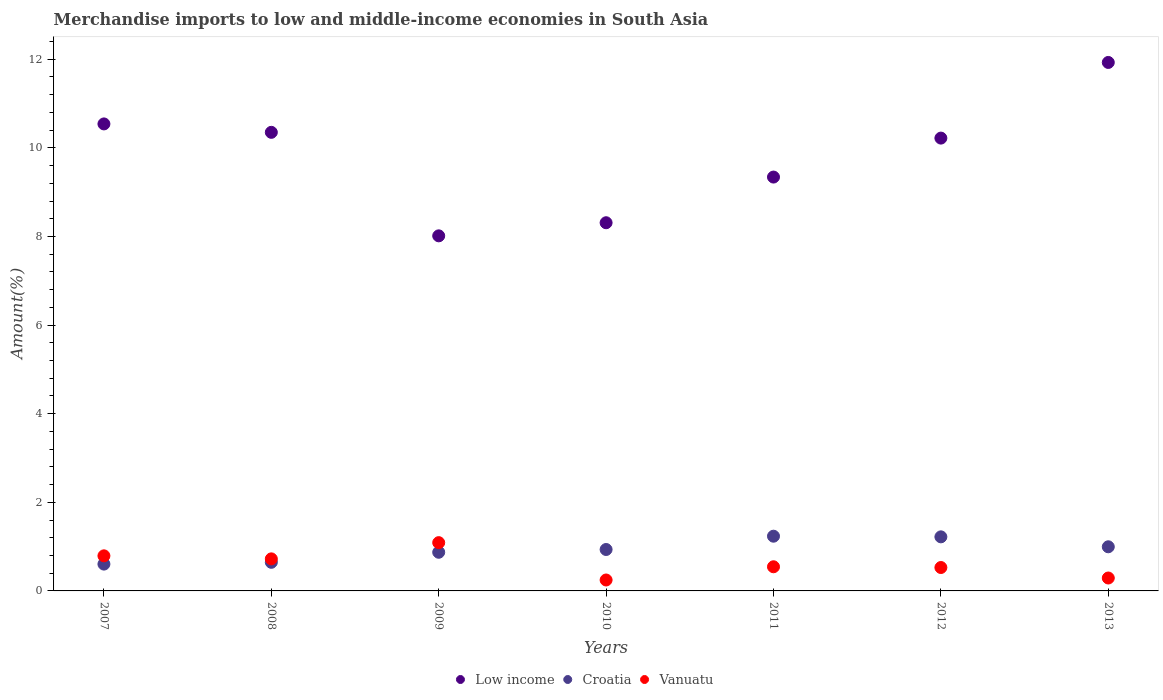What is the percentage of amount earned from merchandise imports in Croatia in 2011?
Make the answer very short. 1.24. Across all years, what is the maximum percentage of amount earned from merchandise imports in Croatia?
Your response must be concise. 1.24. Across all years, what is the minimum percentage of amount earned from merchandise imports in Vanuatu?
Your answer should be compact. 0.25. In which year was the percentage of amount earned from merchandise imports in Vanuatu maximum?
Offer a very short reply. 2009. What is the total percentage of amount earned from merchandise imports in Vanuatu in the graph?
Your answer should be compact. 4.22. What is the difference between the percentage of amount earned from merchandise imports in Low income in 2007 and that in 2011?
Your answer should be compact. 1.2. What is the difference between the percentage of amount earned from merchandise imports in Low income in 2010 and the percentage of amount earned from merchandise imports in Croatia in 2007?
Offer a very short reply. 7.7. What is the average percentage of amount earned from merchandise imports in Croatia per year?
Offer a terse response. 0.93. In the year 2010, what is the difference between the percentage of amount earned from merchandise imports in Low income and percentage of amount earned from merchandise imports in Croatia?
Provide a succinct answer. 7.38. What is the ratio of the percentage of amount earned from merchandise imports in Croatia in 2008 to that in 2013?
Give a very brief answer. 0.65. What is the difference between the highest and the second highest percentage of amount earned from merchandise imports in Vanuatu?
Your answer should be compact. 0.3. What is the difference between the highest and the lowest percentage of amount earned from merchandise imports in Low income?
Provide a succinct answer. 3.91. In how many years, is the percentage of amount earned from merchandise imports in Low income greater than the average percentage of amount earned from merchandise imports in Low income taken over all years?
Give a very brief answer. 4. Is the sum of the percentage of amount earned from merchandise imports in Croatia in 2010 and 2013 greater than the maximum percentage of amount earned from merchandise imports in Low income across all years?
Offer a very short reply. No. Does the percentage of amount earned from merchandise imports in Croatia monotonically increase over the years?
Ensure brevity in your answer.  No. Is the percentage of amount earned from merchandise imports in Croatia strictly greater than the percentage of amount earned from merchandise imports in Vanuatu over the years?
Provide a short and direct response. No. What is the difference between two consecutive major ticks on the Y-axis?
Your response must be concise. 2. Are the values on the major ticks of Y-axis written in scientific E-notation?
Offer a terse response. No. Does the graph contain any zero values?
Keep it short and to the point. No. How are the legend labels stacked?
Offer a very short reply. Horizontal. What is the title of the graph?
Offer a very short reply. Merchandise imports to low and middle-income economies in South Asia. Does "Syrian Arab Republic" appear as one of the legend labels in the graph?
Give a very brief answer. No. What is the label or title of the Y-axis?
Provide a succinct answer. Amount(%). What is the Amount(%) of Low income in 2007?
Give a very brief answer. 10.54. What is the Amount(%) in Croatia in 2007?
Provide a succinct answer. 0.61. What is the Amount(%) of Vanuatu in 2007?
Ensure brevity in your answer.  0.79. What is the Amount(%) in Low income in 2008?
Your answer should be very brief. 10.35. What is the Amount(%) in Croatia in 2008?
Make the answer very short. 0.65. What is the Amount(%) of Vanuatu in 2008?
Your answer should be compact. 0.72. What is the Amount(%) in Low income in 2009?
Make the answer very short. 8.01. What is the Amount(%) in Croatia in 2009?
Offer a very short reply. 0.87. What is the Amount(%) of Vanuatu in 2009?
Give a very brief answer. 1.09. What is the Amount(%) of Low income in 2010?
Ensure brevity in your answer.  8.31. What is the Amount(%) of Croatia in 2010?
Make the answer very short. 0.93. What is the Amount(%) of Vanuatu in 2010?
Give a very brief answer. 0.25. What is the Amount(%) of Low income in 2011?
Ensure brevity in your answer.  9.34. What is the Amount(%) of Croatia in 2011?
Keep it short and to the point. 1.24. What is the Amount(%) of Vanuatu in 2011?
Your answer should be compact. 0.54. What is the Amount(%) in Low income in 2012?
Keep it short and to the point. 10.22. What is the Amount(%) in Croatia in 2012?
Make the answer very short. 1.22. What is the Amount(%) of Vanuatu in 2012?
Your answer should be compact. 0.53. What is the Amount(%) of Low income in 2013?
Your answer should be very brief. 11.93. What is the Amount(%) in Croatia in 2013?
Give a very brief answer. 1. What is the Amount(%) in Vanuatu in 2013?
Offer a terse response. 0.29. Across all years, what is the maximum Amount(%) of Low income?
Ensure brevity in your answer.  11.93. Across all years, what is the maximum Amount(%) of Croatia?
Provide a succinct answer. 1.24. Across all years, what is the maximum Amount(%) in Vanuatu?
Provide a short and direct response. 1.09. Across all years, what is the minimum Amount(%) of Low income?
Offer a terse response. 8.01. Across all years, what is the minimum Amount(%) of Croatia?
Give a very brief answer. 0.61. Across all years, what is the minimum Amount(%) in Vanuatu?
Your answer should be compact. 0.25. What is the total Amount(%) in Low income in the graph?
Provide a short and direct response. 68.71. What is the total Amount(%) in Croatia in the graph?
Keep it short and to the point. 6.51. What is the total Amount(%) of Vanuatu in the graph?
Provide a short and direct response. 4.22. What is the difference between the Amount(%) in Low income in 2007 and that in 2008?
Offer a very short reply. 0.19. What is the difference between the Amount(%) in Croatia in 2007 and that in 2008?
Give a very brief answer. -0.04. What is the difference between the Amount(%) of Vanuatu in 2007 and that in 2008?
Ensure brevity in your answer.  0.07. What is the difference between the Amount(%) in Low income in 2007 and that in 2009?
Ensure brevity in your answer.  2.53. What is the difference between the Amount(%) of Croatia in 2007 and that in 2009?
Your response must be concise. -0.27. What is the difference between the Amount(%) in Vanuatu in 2007 and that in 2009?
Provide a succinct answer. -0.3. What is the difference between the Amount(%) of Low income in 2007 and that in 2010?
Keep it short and to the point. 2.23. What is the difference between the Amount(%) of Croatia in 2007 and that in 2010?
Provide a succinct answer. -0.33. What is the difference between the Amount(%) in Vanuatu in 2007 and that in 2010?
Make the answer very short. 0.55. What is the difference between the Amount(%) of Low income in 2007 and that in 2011?
Provide a succinct answer. 1.2. What is the difference between the Amount(%) in Croatia in 2007 and that in 2011?
Offer a very short reply. -0.63. What is the difference between the Amount(%) in Vanuatu in 2007 and that in 2011?
Offer a terse response. 0.25. What is the difference between the Amount(%) of Low income in 2007 and that in 2012?
Your response must be concise. 0.32. What is the difference between the Amount(%) in Croatia in 2007 and that in 2012?
Keep it short and to the point. -0.62. What is the difference between the Amount(%) in Vanuatu in 2007 and that in 2012?
Your answer should be compact. 0.26. What is the difference between the Amount(%) of Low income in 2007 and that in 2013?
Make the answer very short. -1.39. What is the difference between the Amount(%) in Croatia in 2007 and that in 2013?
Give a very brief answer. -0.39. What is the difference between the Amount(%) of Vanuatu in 2007 and that in 2013?
Provide a short and direct response. 0.5. What is the difference between the Amount(%) of Low income in 2008 and that in 2009?
Keep it short and to the point. 2.34. What is the difference between the Amount(%) of Croatia in 2008 and that in 2009?
Give a very brief answer. -0.23. What is the difference between the Amount(%) in Vanuatu in 2008 and that in 2009?
Offer a terse response. -0.37. What is the difference between the Amount(%) in Low income in 2008 and that in 2010?
Provide a succinct answer. 2.04. What is the difference between the Amount(%) of Croatia in 2008 and that in 2010?
Your answer should be compact. -0.29. What is the difference between the Amount(%) in Vanuatu in 2008 and that in 2010?
Offer a very short reply. 0.48. What is the difference between the Amount(%) in Low income in 2008 and that in 2011?
Your response must be concise. 1.01. What is the difference between the Amount(%) in Croatia in 2008 and that in 2011?
Provide a succinct answer. -0.59. What is the difference between the Amount(%) in Vanuatu in 2008 and that in 2011?
Make the answer very short. 0.18. What is the difference between the Amount(%) of Low income in 2008 and that in 2012?
Keep it short and to the point. 0.13. What is the difference between the Amount(%) of Croatia in 2008 and that in 2012?
Keep it short and to the point. -0.57. What is the difference between the Amount(%) of Vanuatu in 2008 and that in 2012?
Make the answer very short. 0.2. What is the difference between the Amount(%) of Low income in 2008 and that in 2013?
Give a very brief answer. -1.58. What is the difference between the Amount(%) of Croatia in 2008 and that in 2013?
Keep it short and to the point. -0.35. What is the difference between the Amount(%) in Vanuatu in 2008 and that in 2013?
Provide a succinct answer. 0.43. What is the difference between the Amount(%) in Low income in 2009 and that in 2010?
Provide a short and direct response. -0.3. What is the difference between the Amount(%) of Croatia in 2009 and that in 2010?
Give a very brief answer. -0.06. What is the difference between the Amount(%) in Vanuatu in 2009 and that in 2010?
Offer a very short reply. 0.84. What is the difference between the Amount(%) of Low income in 2009 and that in 2011?
Provide a succinct answer. -1.33. What is the difference between the Amount(%) in Croatia in 2009 and that in 2011?
Give a very brief answer. -0.36. What is the difference between the Amount(%) of Vanuatu in 2009 and that in 2011?
Your answer should be compact. 0.54. What is the difference between the Amount(%) of Low income in 2009 and that in 2012?
Ensure brevity in your answer.  -2.21. What is the difference between the Amount(%) of Croatia in 2009 and that in 2012?
Give a very brief answer. -0.35. What is the difference between the Amount(%) of Vanuatu in 2009 and that in 2012?
Offer a terse response. 0.56. What is the difference between the Amount(%) in Low income in 2009 and that in 2013?
Your answer should be very brief. -3.91. What is the difference between the Amount(%) in Croatia in 2009 and that in 2013?
Provide a succinct answer. -0.12. What is the difference between the Amount(%) of Vanuatu in 2009 and that in 2013?
Keep it short and to the point. 0.8. What is the difference between the Amount(%) of Low income in 2010 and that in 2011?
Your answer should be very brief. -1.03. What is the difference between the Amount(%) of Croatia in 2010 and that in 2011?
Your answer should be very brief. -0.3. What is the difference between the Amount(%) of Vanuatu in 2010 and that in 2011?
Ensure brevity in your answer.  -0.3. What is the difference between the Amount(%) in Low income in 2010 and that in 2012?
Keep it short and to the point. -1.91. What is the difference between the Amount(%) of Croatia in 2010 and that in 2012?
Your answer should be very brief. -0.29. What is the difference between the Amount(%) in Vanuatu in 2010 and that in 2012?
Provide a succinct answer. -0.28. What is the difference between the Amount(%) in Low income in 2010 and that in 2013?
Keep it short and to the point. -3.62. What is the difference between the Amount(%) of Croatia in 2010 and that in 2013?
Keep it short and to the point. -0.06. What is the difference between the Amount(%) in Vanuatu in 2010 and that in 2013?
Make the answer very short. -0.04. What is the difference between the Amount(%) of Low income in 2011 and that in 2012?
Your answer should be compact. -0.88. What is the difference between the Amount(%) in Croatia in 2011 and that in 2012?
Keep it short and to the point. 0.01. What is the difference between the Amount(%) in Vanuatu in 2011 and that in 2012?
Offer a very short reply. 0.02. What is the difference between the Amount(%) in Low income in 2011 and that in 2013?
Offer a very short reply. -2.59. What is the difference between the Amount(%) in Croatia in 2011 and that in 2013?
Offer a very short reply. 0.24. What is the difference between the Amount(%) in Vanuatu in 2011 and that in 2013?
Provide a short and direct response. 0.25. What is the difference between the Amount(%) in Low income in 2012 and that in 2013?
Keep it short and to the point. -1.71. What is the difference between the Amount(%) in Croatia in 2012 and that in 2013?
Your answer should be very brief. 0.22. What is the difference between the Amount(%) of Vanuatu in 2012 and that in 2013?
Offer a very short reply. 0.24. What is the difference between the Amount(%) of Low income in 2007 and the Amount(%) of Croatia in 2008?
Keep it short and to the point. 9.89. What is the difference between the Amount(%) in Low income in 2007 and the Amount(%) in Vanuatu in 2008?
Your answer should be compact. 9.82. What is the difference between the Amount(%) in Croatia in 2007 and the Amount(%) in Vanuatu in 2008?
Your response must be concise. -0.12. What is the difference between the Amount(%) of Low income in 2007 and the Amount(%) of Croatia in 2009?
Offer a terse response. 9.67. What is the difference between the Amount(%) of Low income in 2007 and the Amount(%) of Vanuatu in 2009?
Your answer should be compact. 9.45. What is the difference between the Amount(%) in Croatia in 2007 and the Amount(%) in Vanuatu in 2009?
Keep it short and to the point. -0.48. What is the difference between the Amount(%) of Low income in 2007 and the Amount(%) of Croatia in 2010?
Make the answer very short. 9.61. What is the difference between the Amount(%) in Low income in 2007 and the Amount(%) in Vanuatu in 2010?
Your response must be concise. 10.29. What is the difference between the Amount(%) of Croatia in 2007 and the Amount(%) of Vanuatu in 2010?
Your answer should be very brief. 0.36. What is the difference between the Amount(%) of Low income in 2007 and the Amount(%) of Croatia in 2011?
Provide a short and direct response. 9.31. What is the difference between the Amount(%) in Low income in 2007 and the Amount(%) in Vanuatu in 2011?
Offer a terse response. 10. What is the difference between the Amount(%) in Croatia in 2007 and the Amount(%) in Vanuatu in 2011?
Offer a terse response. 0.06. What is the difference between the Amount(%) of Low income in 2007 and the Amount(%) of Croatia in 2012?
Your answer should be compact. 9.32. What is the difference between the Amount(%) in Low income in 2007 and the Amount(%) in Vanuatu in 2012?
Your answer should be compact. 10.01. What is the difference between the Amount(%) of Croatia in 2007 and the Amount(%) of Vanuatu in 2012?
Your response must be concise. 0.08. What is the difference between the Amount(%) of Low income in 2007 and the Amount(%) of Croatia in 2013?
Make the answer very short. 9.54. What is the difference between the Amount(%) of Low income in 2007 and the Amount(%) of Vanuatu in 2013?
Offer a very short reply. 10.25. What is the difference between the Amount(%) in Croatia in 2007 and the Amount(%) in Vanuatu in 2013?
Provide a short and direct response. 0.31. What is the difference between the Amount(%) in Low income in 2008 and the Amount(%) in Croatia in 2009?
Make the answer very short. 9.48. What is the difference between the Amount(%) in Low income in 2008 and the Amount(%) in Vanuatu in 2009?
Your answer should be very brief. 9.26. What is the difference between the Amount(%) of Croatia in 2008 and the Amount(%) of Vanuatu in 2009?
Offer a very short reply. -0.44. What is the difference between the Amount(%) in Low income in 2008 and the Amount(%) in Croatia in 2010?
Provide a short and direct response. 9.42. What is the difference between the Amount(%) in Low income in 2008 and the Amount(%) in Vanuatu in 2010?
Your answer should be compact. 10.1. What is the difference between the Amount(%) in Croatia in 2008 and the Amount(%) in Vanuatu in 2010?
Keep it short and to the point. 0.4. What is the difference between the Amount(%) of Low income in 2008 and the Amount(%) of Croatia in 2011?
Provide a short and direct response. 9.12. What is the difference between the Amount(%) in Low income in 2008 and the Amount(%) in Vanuatu in 2011?
Make the answer very short. 9.81. What is the difference between the Amount(%) in Croatia in 2008 and the Amount(%) in Vanuatu in 2011?
Provide a short and direct response. 0.1. What is the difference between the Amount(%) of Low income in 2008 and the Amount(%) of Croatia in 2012?
Give a very brief answer. 9.13. What is the difference between the Amount(%) in Low income in 2008 and the Amount(%) in Vanuatu in 2012?
Ensure brevity in your answer.  9.82. What is the difference between the Amount(%) in Croatia in 2008 and the Amount(%) in Vanuatu in 2012?
Ensure brevity in your answer.  0.12. What is the difference between the Amount(%) of Low income in 2008 and the Amount(%) of Croatia in 2013?
Your answer should be compact. 9.35. What is the difference between the Amount(%) in Low income in 2008 and the Amount(%) in Vanuatu in 2013?
Offer a very short reply. 10.06. What is the difference between the Amount(%) of Croatia in 2008 and the Amount(%) of Vanuatu in 2013?
Give a very brief answer. 0.35. What is the difference between the Amount(%) in Low income in 2009 and the Amount(%) in Croatia in 2010?
Provide a succinct answer. 7.08. What is the difference between the Amount(%) of Low income in 2009 and the Amount(%) of Vanuatu in 2010?
Provide a short and direct response. 7.77. What is the difference between the Amount(%) in Croatia in 2009 and the Amount(%) in Vanuatu in 2010?
Your response must be concise. 0.63. What is the difference between the Amount(%) of Low income in 2009 and the Amount(%) of Croatia in 2011?
Your answer should be compact. 6.78. What is the difference between the Amount(%) in Low income in 2009 and the Amount(%) in Vanuatu in 2011?
Give a very brief answer. 7.47. What is the difference between the Amount(%) of Croatia in 2009 and the Amount(%) of Vanuatu in 2011?
Offer a terse response. 0.33. What is the difference between the Amount(%) of Low income in 2009 and the Amount(%) of Croatia in 2012?
Your response must be concise. 6.79. What is the difference between the Amount(%) in Low income in 2009 and the Amount(%) in Vanuatu in 2012?
Make the answer very short. 7.49. What is the difference between the Amount(%) of Croatia in 2009 and the Amount(%) of Vanuatu in 2012?
Keep it short and to the point. 0.34. What is the difference between the Amount(%) in Low income in 2009 and the Amount(%) in Croatia in 2013?
Your response must be concise. 7.02. What is the difference between the Amount(%) of Low income in 2009 and the Amount(%) of Vanuatu in 2013?
Offer a very short reply. 7.72. What is the difference between the Amount(%) in Croatia in 2009 and the Amount(%) in Vanuatu in 2013?
Give a very brief answer. 0.58. What is the difference between the Amount(%) of Low income in 2010 and the Amount(%) of Croatia in 2011?
Provide a succinct answer. 7.08. What is the difference between the Amount(%) of Low income in 2010 and the Amount(%) of Vanuatu in 2011?
Your answer should be compact. 7.77. What is the difference between the Amount(%) in Croatia in 2010 and the Amount(%) in Vanuatu in 2011?
Make the answer very short. 0.39. What is the difference between the Amount(%) of Low income in 2010 and the Amount(%) of Croatia in 2012?
Your response must be concise. 7.09. What is the difference between the Amount(%) in Low income in 2010 and the Amount(%) in Vanuatu in 2012?
Keep it short and to the point. 7.78. What is the difference between the Amount(%) of Croatia in 2010 and the Amount(%) of Vanuatu in 2012?
Your answer should be compact. 0.41. What is the difference between the Amount(%) of Low income in 2010 and the Amount(%) of Croatia in 2013?
Give a very brief answer. 7.31. What is the difference between the Amount(%) of Low income in 2010 and the Amount(%) of Vanuatu in 2013?
Your answer should be very brief. 8.02. What is the difference between the Amount(%) in Croatia in 2010 and the Amount(%) in Vanuatu in 2013?
Your answer should be compact. 0.64. What is the difference between the Amount(%) of Low income in 2011 and the Amount(%) of Croatia in 2012?
Your answer should be very brief. 8.12. What is the difference between the Amount(%) of Low income in 2011 and the Amount(%) of Vanuatu in 2012?
Offer a very short reply. 8.81. What is the difference between the Amount(%) in Croatia in 2011 and the Amount(%) in Vanuatu in 2012?
Offer a terse response. 0.71. What is the difference between the Amount(%) in Low income in 2011 and the Amount(%) in Croatia in 2013?
Offer a very short reply. 8.34. What is the difference between the Amount(%) in Low income in 2011 and the Amount(%) in Vanuatu in 2013?
Your response must be concise. 9.05. What is the difference between the Amount(%) in Croatia in 2011 and the Amount(%) in Vanuatu in 2013?
Your response must be concise. 0.94. What is the difference between the Amount(%) in Low income in 2012 and the Amount(%) in Croatia in 2013?
Ensure brevity in your answer.  9.22. What is the difference between the Amount(%) in Low income in 2012 and the Amount(%) in Vanuatu in 2013?
Offer a very short reply. 9.93. What is the difference between the Amount(%) in Croatia in 2012 and the Amount(%) in Vanuatu in 2013?
Give a very brief answer. 0.93. What is the average Amount(%) in Low income per year?
Your answer should be very brief. 9.82. What is the average Amount(%) in Croatia per year?
Ensure brevity in your answer.  0.93. What is the average Amount(%) of Vanuatu per year?
Your answer should be very brief. 0.6. In the year 2007, what is the difference between the Amount(%) in Low income and Amount(%) in Croatia?
Provide a short and direct response. 9.94. In the year 2007, what is the difference between the Amount(%) of Low income and Amount(%) of Vanuatu?
Your answer should be compact. 9.75. In the year 2007, what is the difference between the Amount(%) of Croatia and Amount(%) of Vanuatu?
Give a very brief answer. -0.19. In the year 2008, what is the difference between the Amount(%) in Low income and Amount(%) in Croatia?
Offer a very short reply. 9.7. In the year 2008, what is the difference between the Amount(%) of Low income and Amount(%) of Vanuatu?
Keep it short and to the point. 9.63. In the year 2008, what is the difference between the Amount(%) of Croatia and Amount(%) of Vanuatu?
Offer a terse response. -0.08. In the year 2009, what is the difference between the Amount(%) in Low income and Amount(%) in Croatia?
Offer a terse response. 7.14. In the year 2009, what is the difference between the Amount(%) in Low income and Amount(%) in Vanuatu?
Keep it short and to the point. 6.92. In the year 2009, what is the difference between the Amount(%) in Croatia and Amount(%) in Vanuatu?
Your answer should be very brief. -0.22. In the year 2010, what is the difference between the Amount(%) in Low income and Amount(%) in Croatia?
Your answer should be very brief. 7.38. In the year 2010, what is the difference between the Amount(%) in Low income and Amount(%) in Vanuatu?
Give a very brief answer. 8.06. In the year 2010, what is the difference between the Amount(%) in Croatia and Amount(%) in Vanuatu?
Make the answer very short. 0.69. In the year 2011, what is the difference between the Amount(%) of Low income and Amount(%) of Croatia?
Make the answer very short. 8.11. In the year 2011, what is the difference between the Amount(%) of Low income and Amount(%) of Vanuatu?
Provide a succinct answer. 8.8. In the year 2011, what is the difference between the Amount(%) in Croatia and Amount(%) in Vanuatu?
Provide a short and direct response. 0.69. In the year 2012, what is the difference between the Amount(%) in Low income and Amount(%) in Croatia?
Give a very brief answer. 9. In the year 2012, what is the difference between the Amount(%) of Low income and Amount(%) of Vanuatu?
Your response must be concise. 9.69. In the year 2012, what is the difference between the Amount(%) in Croatia and Amount(%) in Vanuatu?
Keep it short and to the point. 0.69. In the year 2013, what is the difference between the Amount(%) in Low income and Amount(%) in Croatia?
Keep it short and to the point. 10.93. In the year 2013, what is the difference between the Amount(%) in Low income and Amount(%) in Vanuatu?
Your answer should be compact. 11.64. In the year 2013, what is the difference between the Amount(%) of Croatia and Amount(%) of Vanuatu?
Offer a very short reply. 0.7. What is the ratio of the Amount(%) of Low income in 2007 to that in 2008?
Provide a succinct answer. 1.02. What is the ratio of the Amount(%) in Croatia in 2007 to that in 2008?
Keep it short and to the point. 0.94. What is the ratio of the Amount(%) in Vanuatu in 2007 to that in 2008?
Keep it short and to the point. 1.09. What is the ratio of the Amount(%) of Low income in 2007 to that in 2009?
Make the answer very short. 1.32. What is the ratio of the Amount(%) of Croatia in 2007 to that in 2009?
Make the answer very short. 0.69. What is the ratio of the Amount(%) of Vanuatu in 2007 to that in 2009?
Provide a succinct answer. 0.73. What is the ratio of the Amount(%) in Low income in 2007 to that in 2010?
Make the answer very short. 1.27. What is the ratio of the Amount(%) of Croatia in 2007 to that in 2010?
Offer a very short reply. 0.65. What is the ratio of the Amount(%) in Vanuatu in 2007 to that in 2010?
Provide a succinct answer. 3.21. What is the ratio of the Amount(%) of Low income in 2007 to that in 2011?
Your response must be concise. 1.13. What is the ratio of the Amount(%) of Croatia in 2007 to that in 2011?
Your answer should be very brief. 0.49. What is the ratio of the Amount(%) in Vanuatu in 2007 to that in 2011?
Provide a succinct answer. 1.45. What is the ratio of the Amount(%) in Low income in 2007 to that in 2012?
Keep it short and to the point. 1.03. What is the ratio of the Amount(%) in Croatia in 2007 to that in 2012?
Offer a terse response. 0.5. What is the ratio of the Amount(%) in Vanuatu in 2007 to that in 2012?
Offer a very short reply. 1.5. What is the ratio of the Amount(%) in Low income in 2007 to that in 2013?
Ensure brevity in your answer.  0.88. What is the ratio of the Amount(%) of Croatia in 2007 to that in 2013?
Give a very brief answer. 0.61. What is the ratio of the Amount(%) in Vanuatu in 2007 to that in 2013?
Your answer should be compact. 2.72. What is the ratio of the Amount(%) in Low income in 2008 to that in 2009?
Your response must be concise. 1.29. What is the ratio of the Amount(%) in Croatia in 2008 to that in 2009?
Offer a terse response. 0.74. What is the ratio of the Amount(%) in Vanuatu in 2008 to that in 2009?
Give a very brief answer. 0.66. What is the ratio of the Amount(%) in Low income in 2008 to that in 2010?
Provide a short and direct response. 1.25. What is the ratio of the Amount(%) in Croatia in 2008 to that in 2010?
Your answer should be compact. 0.69. What is the ratio of the Amount(%) in Vanuatu in 2008 to that in 2010?
Give a very brief answer. 2.93. What is the ratio of the Amount(%) in Low income in 2008 to that in 2011?
Offer a very short reply. 1.11. What is the ratio of the Amount(%) of Croatia in 2008 to that in 2011?
Offer a very short reply. 0.52. What is the ratio of the Amount(%) in Vanuatu in 2008 to that in 2011?
Your response must be concise. 1.33. What is the ratio of the Amount(%) in Low income in 2008 to that in 2012?
Make the answer very short. 1.01. What is the ratio of the Amount(%) in Croatia in 2008 to that in 2012?
Your answer should be very brief. 0.53. What is the ratio of the Amount(%) of Vanuatu in 2008 to that in 2012?
Keep it short and to the point. 1.37. What is the ratio of the Amount(%) of Low income in 2008 to that in 2013?
Your answer should be very brief. 0.87. What is the ratio of the Amount(%) of Croatia in 2008 to that in 2013?
Your response must be concise. 0.65. What is the ratio of the Amount(%) of Vanuatu in 2008 to that in 2013?
Offer a terse response. 2.48. What is the ratio of the Amount(%) of Low income in 2009 to that in 2010?
Your answer should be very brief. 0.96. What is the ratio of the Amount(%) of Croatia in 2009 to that in 2010?
Ensure brevity in your answer.  0.93. What is the ratio of the Amount(%) in Vanuatu in 2009 to that in 2010?
Ensure brevity in your answer.  4.42. What is the ratio of the Amount(%) in Low income in 2009 to that in 2011?
Give a very brief answer. 0.86. What is the ratio of the Amount(%) in Croatia in 2009 to that in 2011?
Your response must be concise. 0.71. What is the ratio of the Amount(%) of Vanuatu in 2009 to that in 2011?
Give a very brief answer. 2. What is the ratio of the Amount(%) in Low income in 2009 to that in 2012?
Your answer should be compact. 0.78. What is the ratio of the Amount(%) of Croatia in 2009 to that in 2012?
Ensure brevity in your answer.  0.71. What is the ratio of the Amount(%) of Vanuatu in 2009 to that in 2012?
Give a very brief answer. 2.06. What is the ratio of the Amount(%) in Low income in 2009 to that in 2013?
Your answer should be very brief. 0.67. What is the ratio of the Amount(%) in Croatia in 2009 to that in 2013?
Provide a short and direct response. 0.88. What is the ratio of the Amount(%) in Vanuatu in 2009 to that in 2013?
Provide a succinct answer. 3.74. What is the ratio of the Amount(%) of Low income in 2010 to that in 2011?
Provide a short and direct response. 0.89. What is the ratio of the Amount(%) in Croatia in 2010 to that in 2011?
Make the answer very short. 0.76. What is the ratio of the Amount(%) of Vanuatu in 2010 to that in 2011?
Your response must be concise. 0.45. What is the ratio of the Amount(%) in Low income in 2010 to that in 2012?
Provide a short and direct response. 0.81. What is the ratio of the Amount(%) of Croatia in 2010 to that in 2012?
Give a very brief answer. 0.77. What is the ratio of the Amount(%) in Vanuatu in 2010 to that in 2012?
Ensure brevity in your answer.  0.47. What is the ratio of the Amount(%) in Low income in 2010 to that in 2013?
Keep it short and to the point. 0.7. What is the ratio of the Amount(%) in Croatia in 2010 to that in 2013?
Give a very brief answer. 0.94. What is the ratio of the Amount(%) of Vanuatu in 2010 to that in 2013?
Your response must be concise. 0.85. What is the ratio of the Amount(%) of Low income in 2011 to that in 2012?
Provide a short and direct response. 0.91. What is the ratio of the Amount(%) in Croatia in 2011 to that in 2012?
Offer a very short reply. 1.01. What is the ratio of the Amount(%) of Vanuatu in 2011 to that in 2012?
Your response must be concise. 1.03. What is the ratio of the Amount(%) in Low income in 2011 to that in 2013?
Your response must be concise. 0.78. What is the ratio of the Amount(%) in Croatia in 2011 to that in 2013?
Give a very brief answer. 1.24. What is the ratio of the Amount(%) in Vanuatu in 2011 to that in 2013?
Give a very brief answer. 1.87. What is the ratio of the Amount(%) in Low income in 2012 to that in 2013?
Provide a short and direct response. 0.86. What is the ratio of the Amount(%) of Croatia in 2012 to that in 2013?
Ensure brevity in your answer.  1.23. What is the ratio of the Amount(%) in Vanuatu in 2012 to that in 2013?
Your answer should be compact. 1.81. What is the difference between the highest and the second highest Amount(%) of Low income?
Keep it short and to the point. 1.39. What is the difference between the highest and the second highest Amount(%) of Croatia?
Provide a succinct answer. 0.01. What is the difference between the highest and the second highest Amount(%) in Vanuatu?
Offer a terse response. 0.3. What is the difference between the highest and the lowest Amount(%) in Low income?
Keep it short and to the point. 3.91. What is the difference between the highest and the lowest Amount(%) of Croatia?
Provide a succinct answer. 0.63. What is the difference between the highest and the lowest Amount(%) of Vanuatu?
Your answer should be very brief. 0.84. 